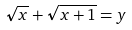Convert formula to latex. <formula><loc_0><loc_0><loc_500><loc_500>\sqrt { x } + \sqrt { x + 1 } = y</formula> 